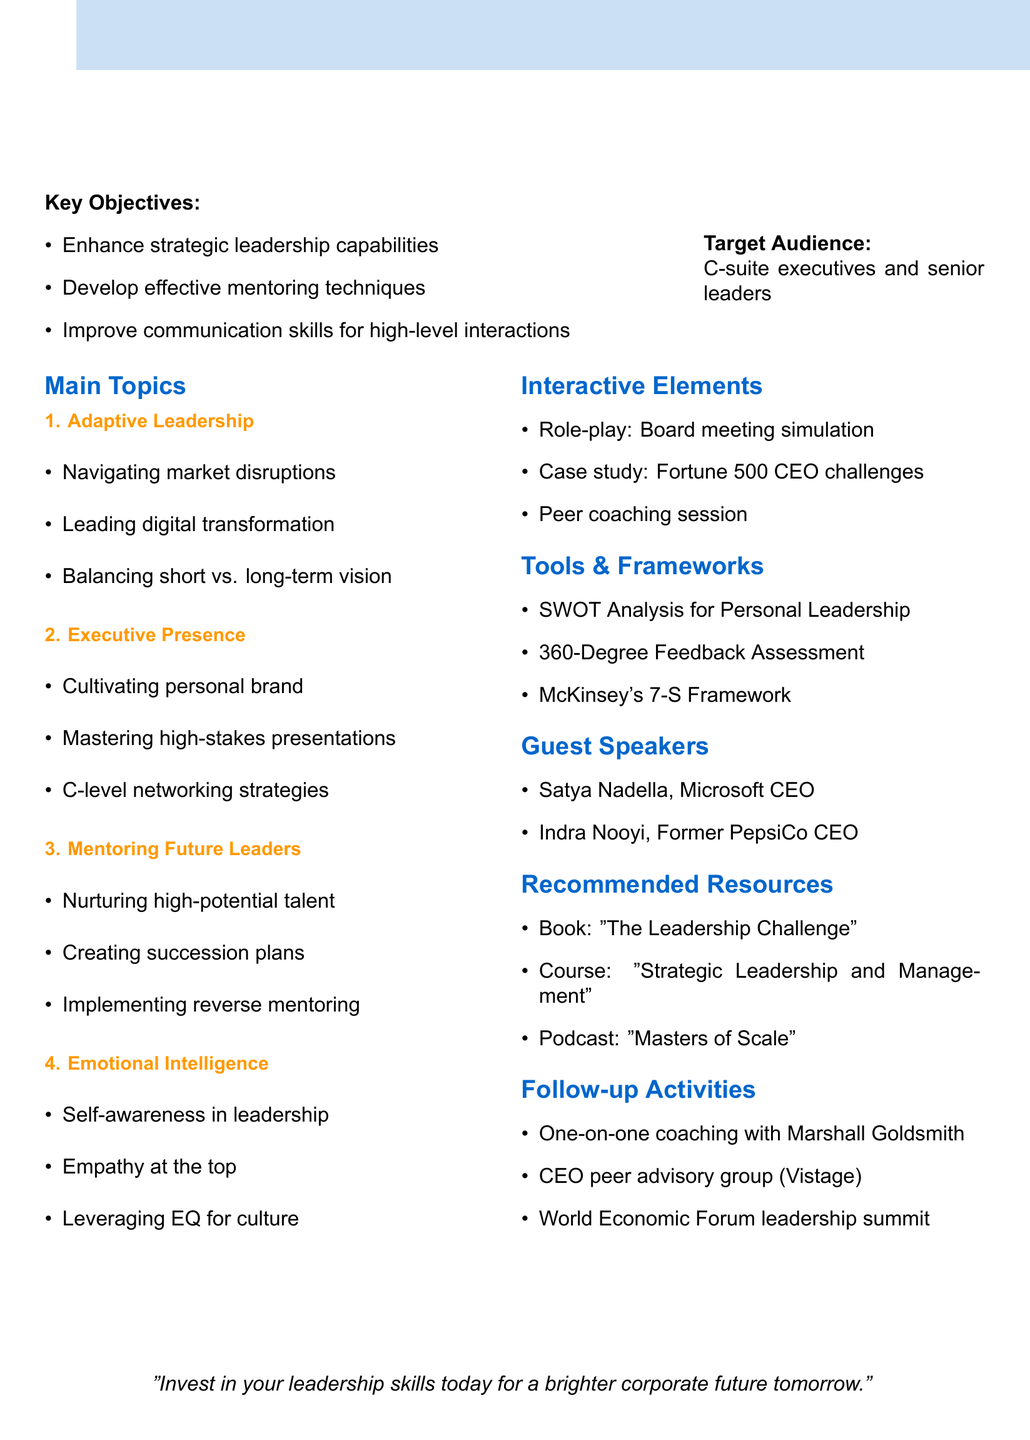What is the title of the session? The title of the session is shown at the beginning of the document, which is "Elevating Leadership: Refining Executive Skills and Mentoring Abilities."
Answer: Elevating Leadership: Refining Executive Skills and Mentoring Abilities Who is the target audience for the session? The target audience specifies the intended participants of the session, which is "C-suite executives and senior leaders."
Answer: C-suite executives and senior leaders How long is the session? The duration of the session is stated clearly, which is "4 hours."
Answer: 4 hours Name a guest speaker for the session. The document lists guest speakers, such as "Satya Nadella" and "Indra Nooyi."
Answer: Satya Nadella What framework is used to align personal leadership with organizational goals? The document mentions that "McKinsey's 7-S Framework" is used for this purpose.
Answer: McKinsey's 7-S Framework What is one of the key objectives of the session? The key objectives are outlined; one is to "Enhance strategic leadership capabilities."
Answer: Enhance strategic leadership capabilities Which interactive element involves simulating a board meeting? The document describes an interactive element called a "Role-playing exercise" that focuses on this simulation.
Answer: Role-playing exercise What type of resource is "The Leadership Challenge"? The document categorizes this resource as a "Book."
Answer: Book What follow-up activity involves attending a leadership summit? The document lists "Attendance at World Economic Forum leadership summit in Davos" as a follow-up activity.
Answer: Attendance at World Economic Forum leadership summit in Davos 